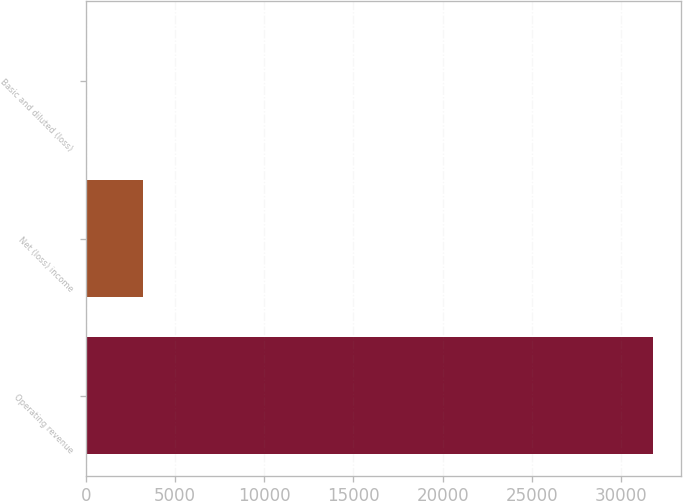<chart> <loc_0><loc_0><loc_500><loc_500><bar_chart><fcel>Operating revenue<fcel>Net (loss) income<fcel>Basic and diluted (loss)<nl><fcel>31781<fcel>3178.77<fcel>0.74<nl></chart> 